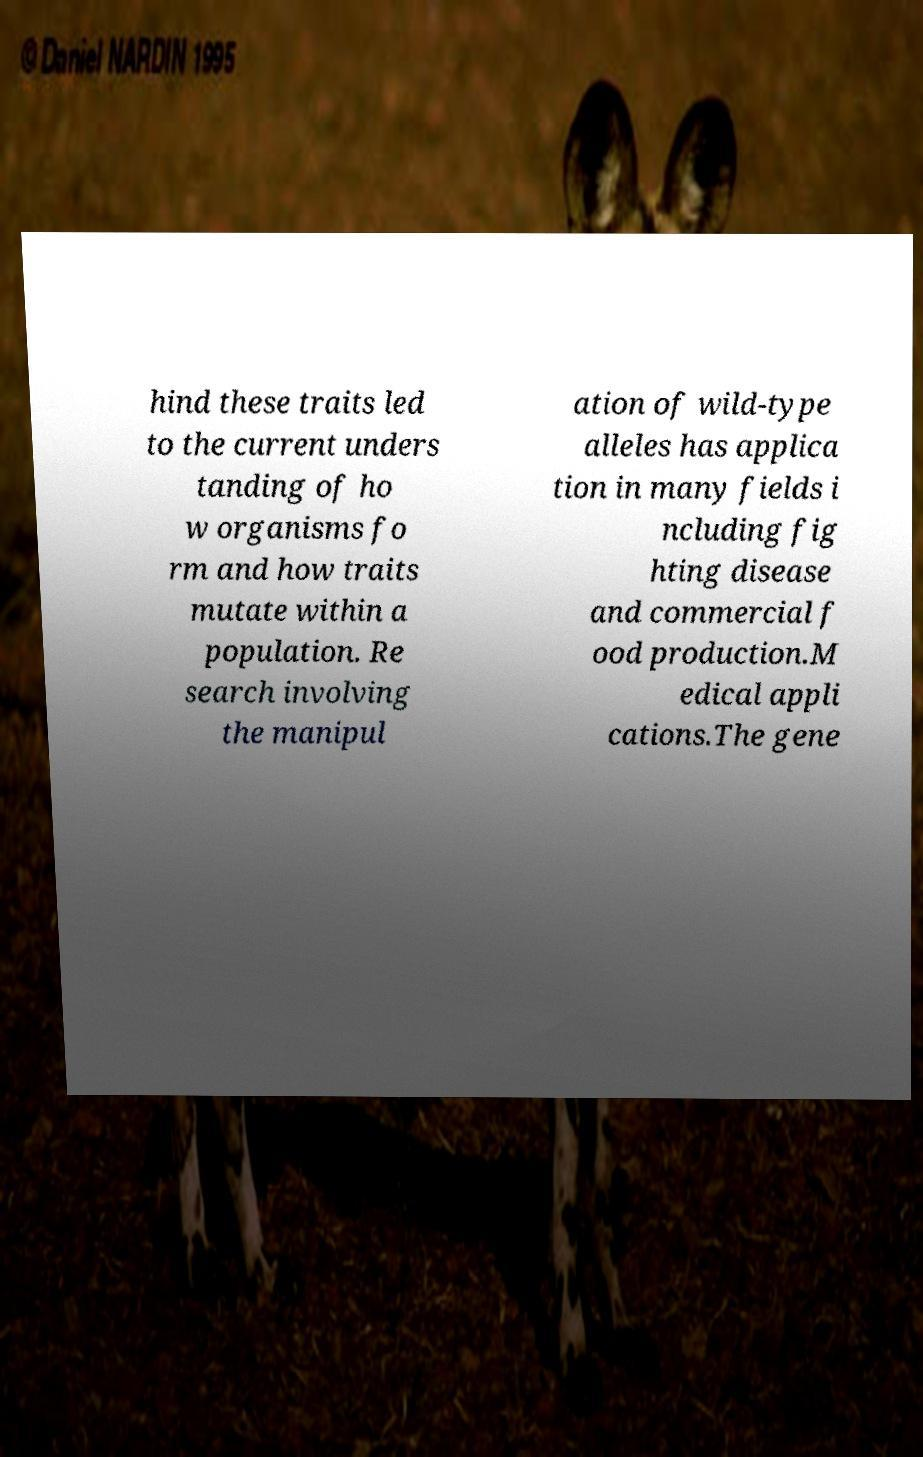What messages or text are displayed in this image? I need them in a readable, typed format. hind these traits led to the current unders tanding of ho w organisms fo rm and how traits mutate within a population. Re search involving the manipul ation of wild-type alleles has applica tion in many fields i ncluding fig hting disease and commercial f ood production.M edical appli cations.The gene 